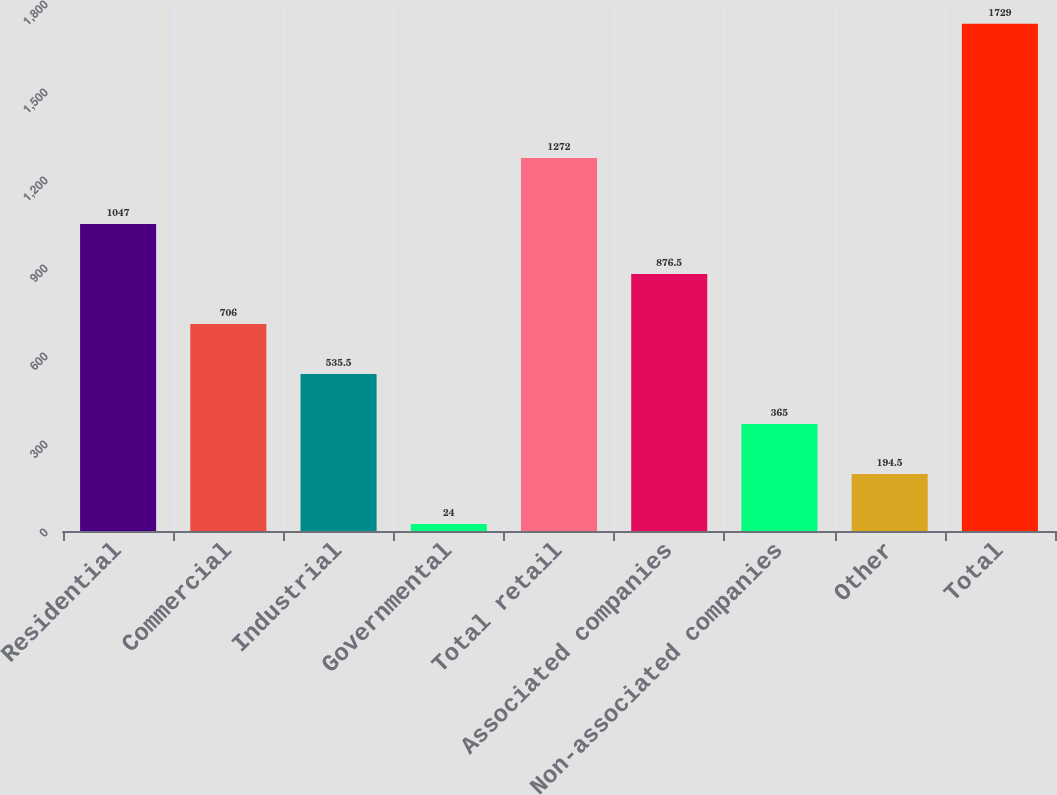Convert chart to OTSL. <chart><loc_0><loc_0><loc_500><loc_500><bar_chart><fcel>Residential<fcel>Commercial<fcel>Industrial<fcel>Governmental<fcel>Total retail<fcel>Associated companies<fcel>Non-associated companies<fcel>Other<fcel>Total<nl><fcel>1047<fcel>706<fcel>535.5<fcel>24<fcel>1272<fcel>876.5<fcel>365<fcel>194.5<fcel>1729<nl></chart> 